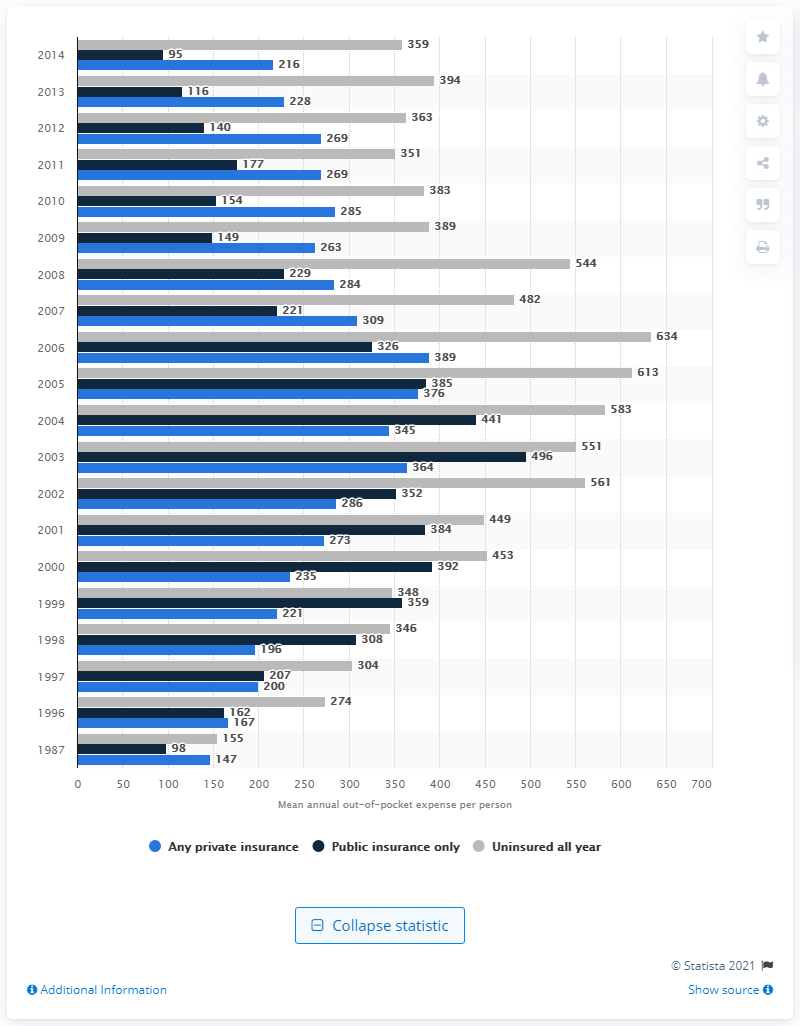Give some essential details in this illustration. In 2014, the average out-of-pocket expense per uninsured person under the age of 65 was $359 per year. 